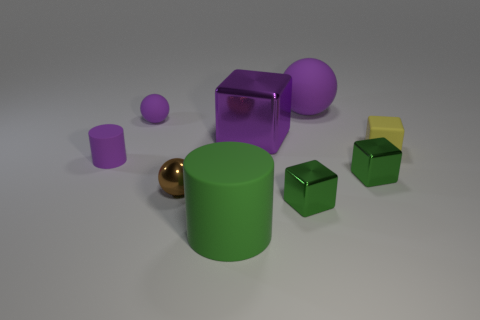There is a purple cylinder; how many big cubes are in front of it? In the image, there are no big cubes positioned in front of the purple cylinder. All cubes, which happen to be green, are either beside or behind the cylinder relative to the viewer's perspective. 